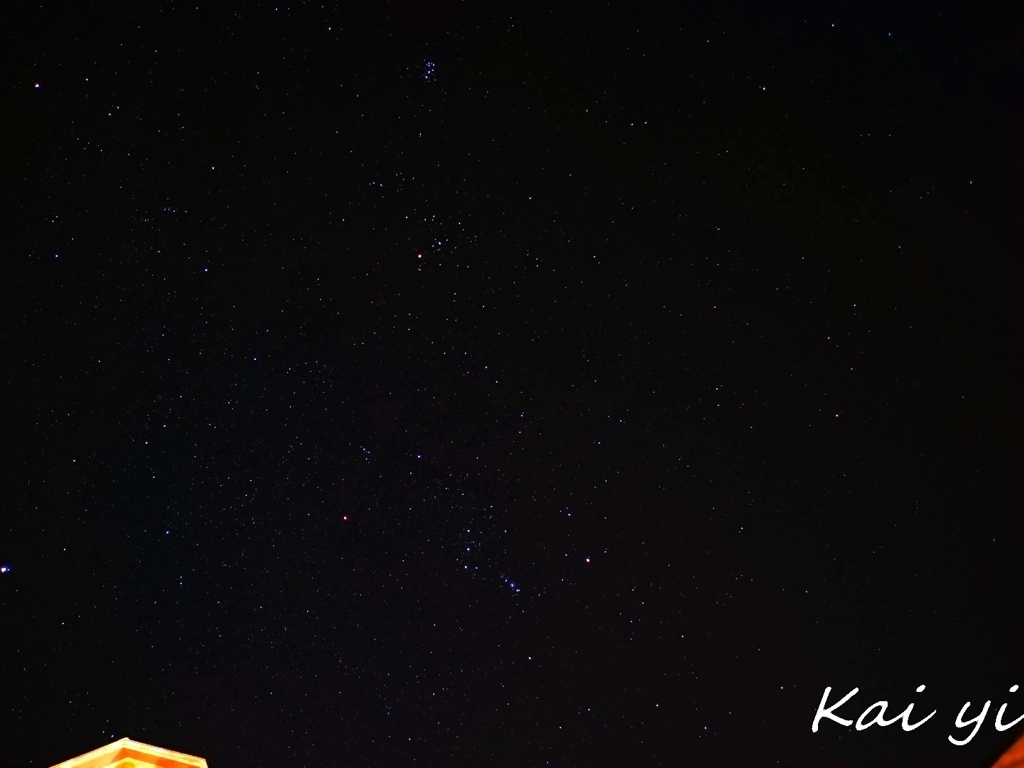What could be the reason for not seeing more details in this night sky? Limited details in the night sky can be a result of various factors, including light pollution from nearby urban areas, which dims the visibility of celestial objects. Inadequate camera settings, like a short exposure time or narrow aperture, can also prevent enough light from reaching the sensor. Moreover, atmospheric conditions, such as humidity or clouds, can obscure finer details, and lesser-quality equipment might be unable to capture more subtle features of the night sky. 